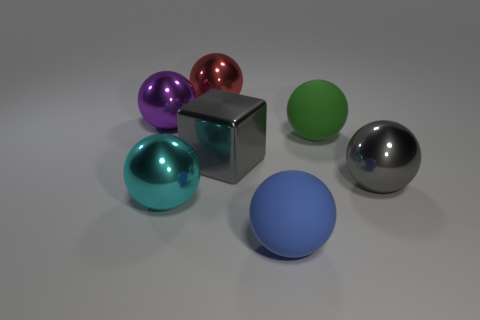Subtract all matte balls. How many balls are left? 4 Add 1 matte spheres. How many objects exist? 8 Subtract all red spheres. How many spheres are left? 5 Subtract all blocks. How many objects are left? 6 Subtract all green spheres. Subtract all purple cubes. How many spheres are left? 5 Subtract all blue matte spheres. Subtract all cyan shiny spheres. How many objects are left? 5 Add 1 green balls. How many green balls are left? 2 Add 6 tiny balls. How many tiny balls exist? 6 Subtract 0 blue cylinders. How many objects are left? 7 